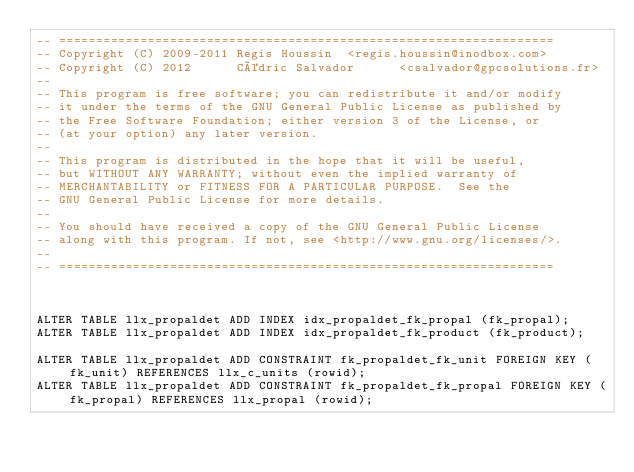<code> <loc_0><loc_0><loc_500><loc_500><_SQL_>-- ===================================================================
-- Copyright (C) 2009-2011 Regis Houssin  <regis.houssin@inodbox.com>
-- Copyright (C) 2012      Cédric Salvador      <csalvador@gpcsolutions.fr>
--
-- This program is free software; you can redistribute it and/or modify
-- it under the terms of the GNU General Public License as published by
-- the Free Software Foundation; either version 3 of the License, or
-- (at your option) any later version.
--
-- This program is distributed in the hope that it will be useful,
-- but WITHOUT ANY WARRANTY; without even the implied warranty of
-- MERCHANTABILITY or FITNESS FOR A PARTICULAR PURPOSE.  See the
-- GNU General Public License for more details.
--
-- You should have received a copy of the GNU General Public License
-- along with this program. If not, see <http://www.gnu.org/licenses/>.
--
-- ===================================================================



ALTER TABLE llx_propaldet ADD INDEX idx_propaldet_fk_propal (fk_propal);
ALTER TABLE llx_propaldet ADD INDEX idx_propaldet_fk_product (fk_product);

ALTER TABLE llx_propaldet ADD CONSTRAINT fk_propaldet_fk_unit FOREIGN KEY (fk_unit) REFERENCES llx_c_units (rowid);
ALTER TABLE llx_propaldet ADD CONSTRAINT fk_propaldet_fk_propal FOREIGN KEY (fk_propal) REFERENCES llx_propal (rowid);
</code> 